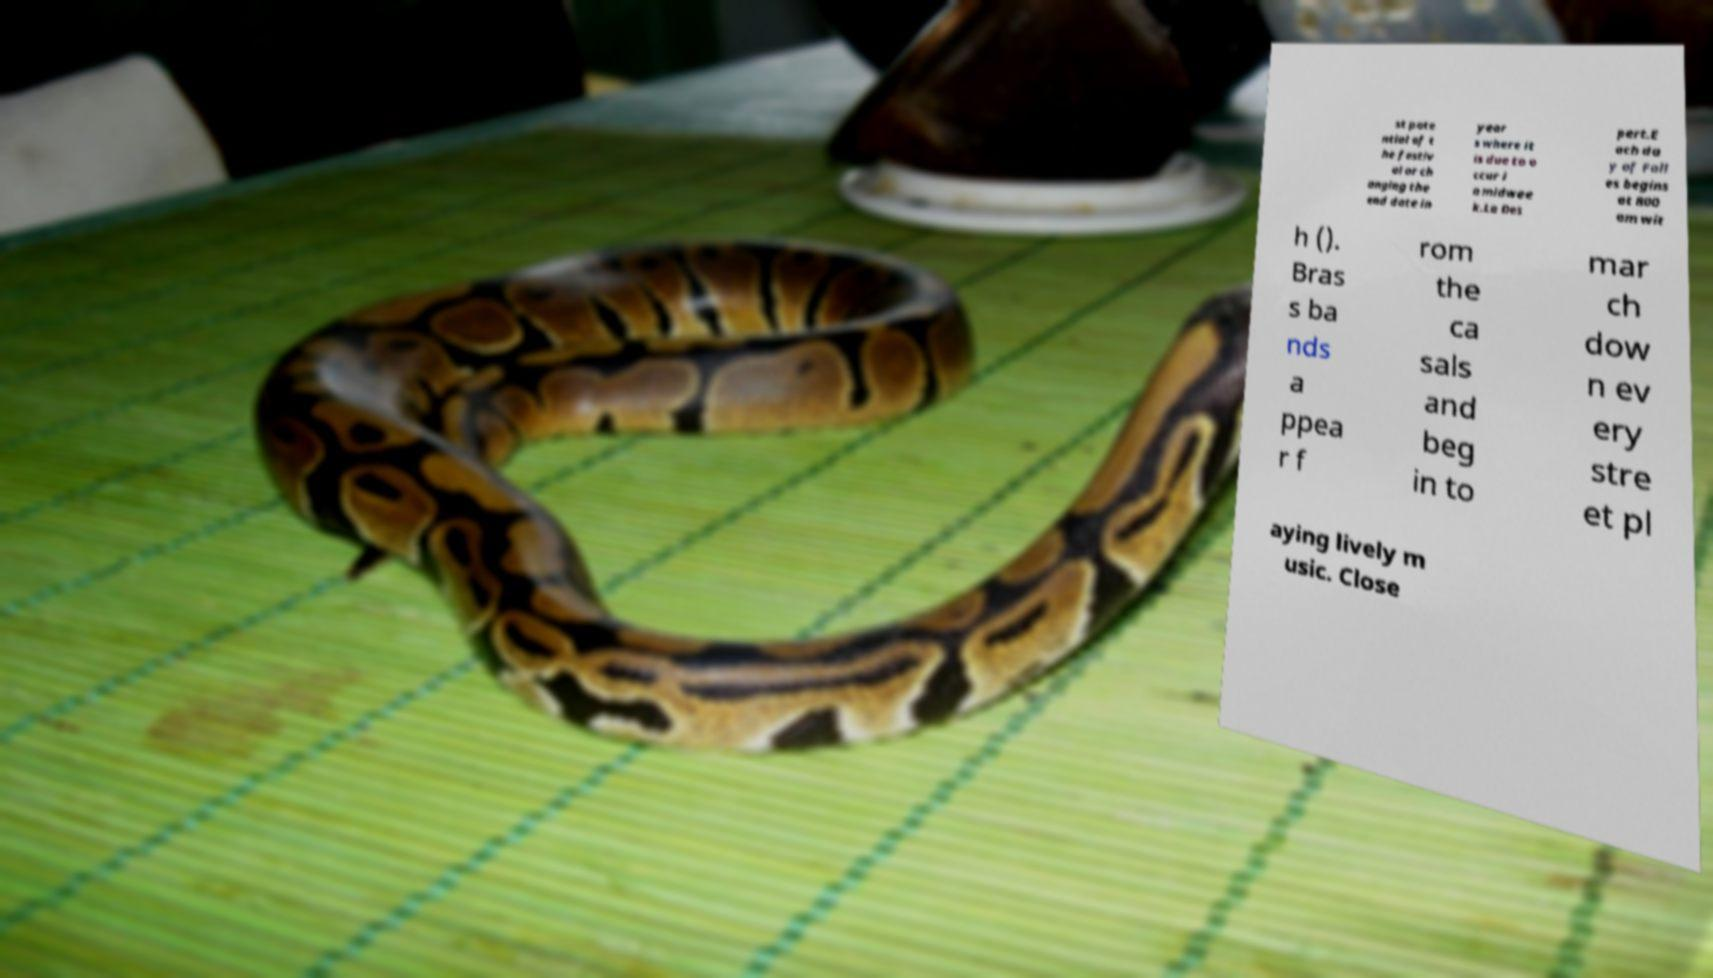Could you assist in decoding the text presented in this image and type it out clearly? st pote ntial of t he festiv al or ch anging the end date in year s where it is due to o ccur i n midwee k.La Des pert.E ach da y of Fall es begins at 800 am wit h (). Bras s ba nds a ppea r f rom the ca sals and beg in to mar ch dow n ev ery stre et pl aying lively m usic. Close 